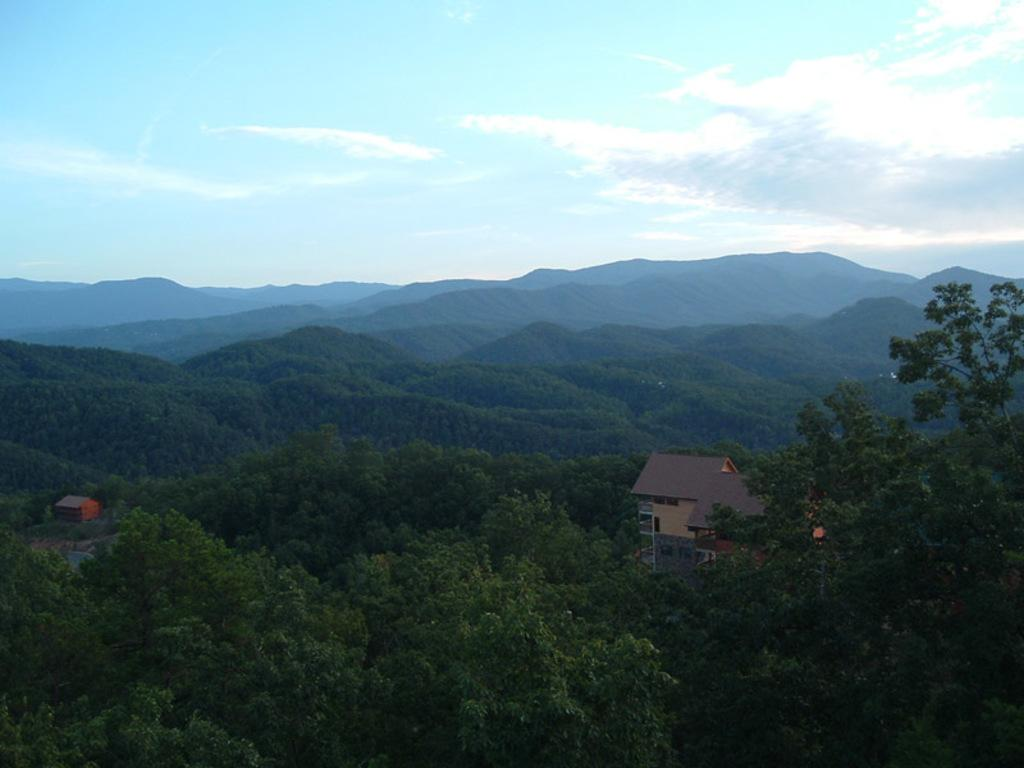What type of natural elements can be seen in the image? There are trees in the image. What type of man-made structures are present in the image? There are houses in the image. What type of geographical feature can be seen in the image? There are mountains in the image. What is visible in the background of the image? The sky is visible in the image. What language is spoken by the trees in the image? Trees do not speak any language, so this question cannot be answered. 